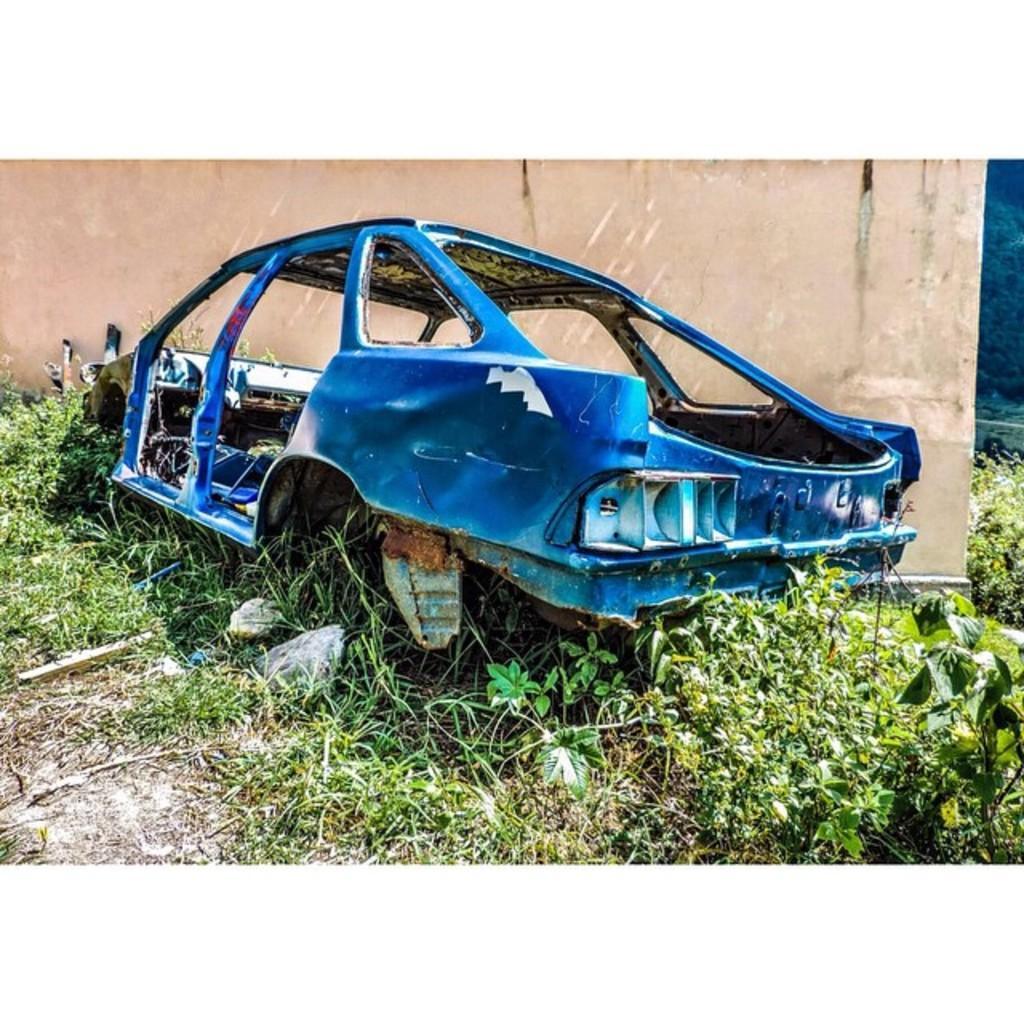Could you give a brief overview of what you see in this image? In this image we can see the frame of a car on the ground. We can also see some plants, grass and a wall. 